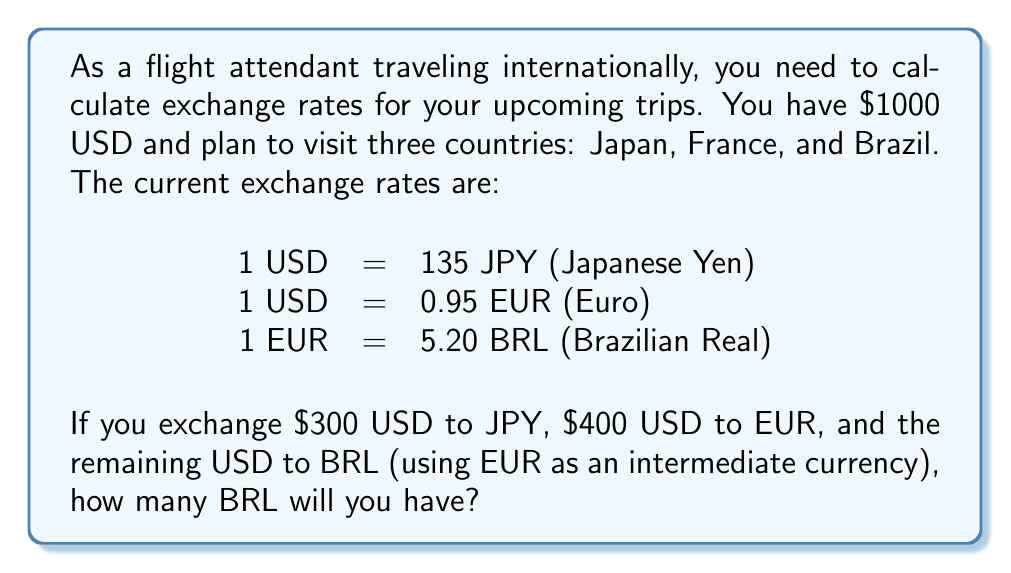Can you solve this math problem? Let's break this down step-by-step:

1. Exchange $300 USD to JPY:
   $$300 \text{ USD} \times 135 \text{ JPY/USD} = 40,500 \text{ JPY}$$

2. Exchange $400 USD to EUR:
   $$400 \text{ USD} \times 0.95 \text{ EUR/USD} = 380 \text{ EUR}$$

3. Calculate remaining USD:
   $$1000 \text{ USD} - 300 \text{ USD} - 400 \text{ USD} = 300 \text{ USD}$$

4. Convert remaining USD to EUR:
   $$300 \text{ USD} \times 0.95 \text{ EUR/USD} = 285 \text{ EUR}$$

5. Calculate total EUR:
   $$380 \text{ EUR} + 285 \text{ EUR} = 665 \text{ EUR}$$

6. Convert total EUR to BRL:
   $$665 \text{ EUR} \times 5.20 \text{ BRL/EUR} = 3,458 \text{ BRL}$$

Therefore, after all the exchanges, you will have 3,458 BRL.
Answer: 3,458 BRL 